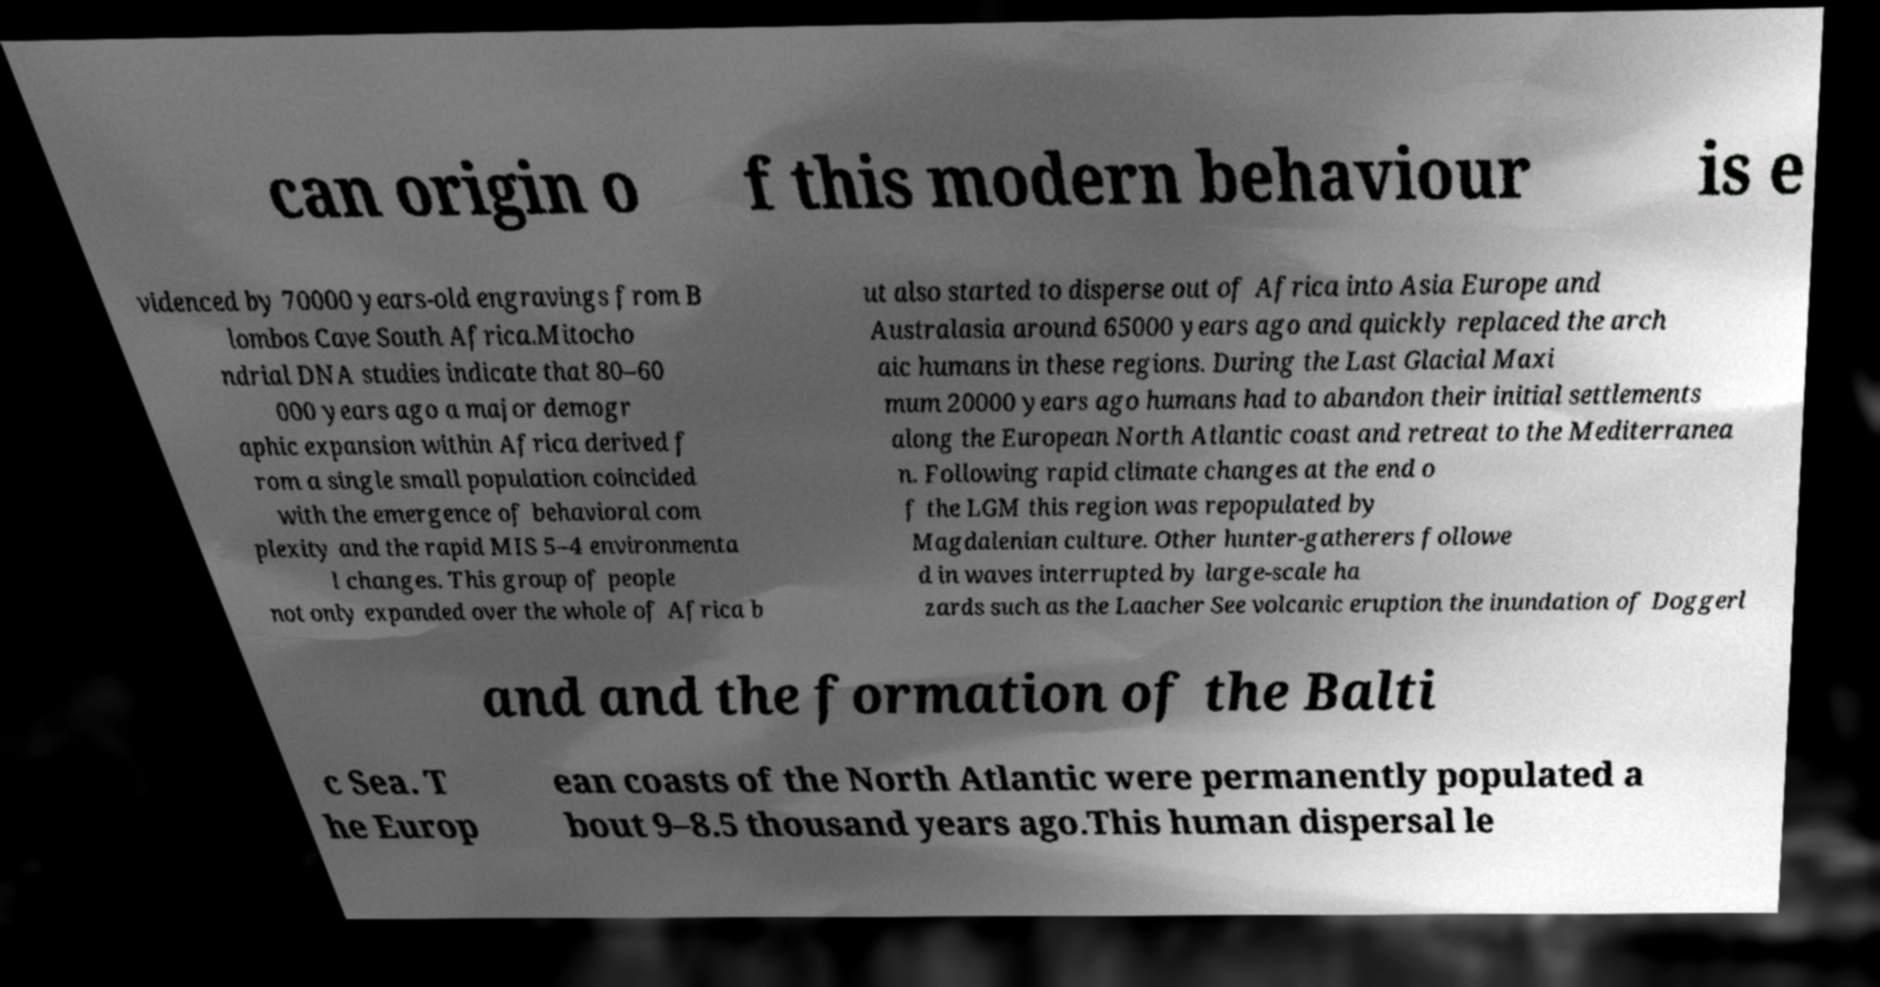Could you extract and type out the text from this image? can origin o f this modern behaviour is e videnced by 70000 years-old engravings from B lombos Cave South Africa.Mitocho ndrial DNA studies indicate that 80–60 000 years ago a major demogr aphic expansion within Africa derived f rom a single small population coincided with the emergence of behavioral com plexity and the rapid MIS 5–4 environmenta l changes. This group of people not only expanded over the whole of Africa b ut also started to disperse out of Africa into Asia Europe and Australasia around 65000 years ago and quickly replaced the arch aic humans in these regions. During the Last Glacial Maxi mum 20000 years ago humans had to abandon their initial settlements along the European North Atlantic coast and retreat to the Mediterranea n. Following rapid climate changes at the end o f the LGM this region was repopulated by Magdalenian culture. Other hunter-gatherers followe d in waves interrupted by large-scale ha zards such as the Laacher See volcanic eruption the inundation of Doggerl and and the formation of the Balti c Sea. T he Europ ean coasts of the North Atlantic were permanently populated a bout 9–8.5 thousand years ago.This human dispersal le 